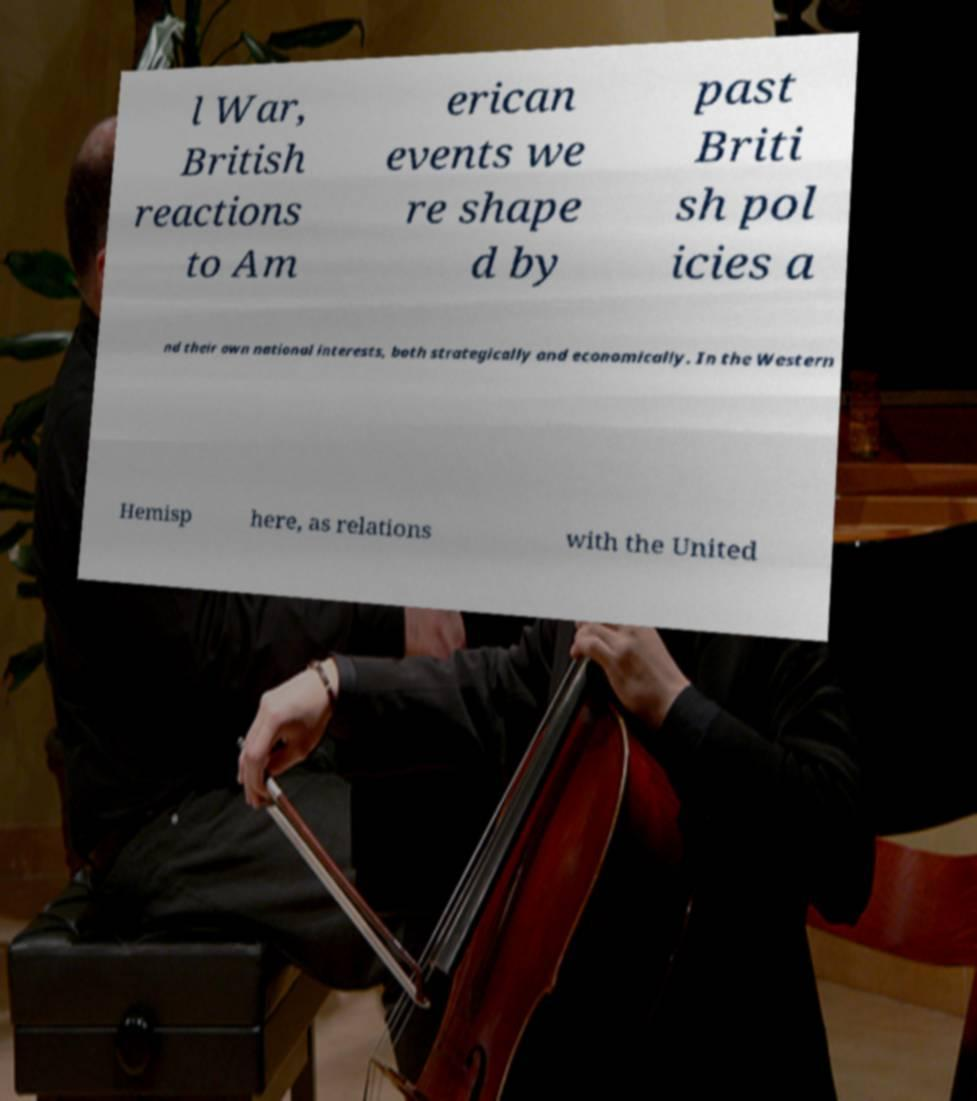For documentation purposes, I need the text within this image transcribed. Could you provide that? l War, British reactions to Am erican events we re shape d by past Briti sh pol icies a nd their own national interests, both strategically and economically. In the Western Hemisp here, as relations with the United 